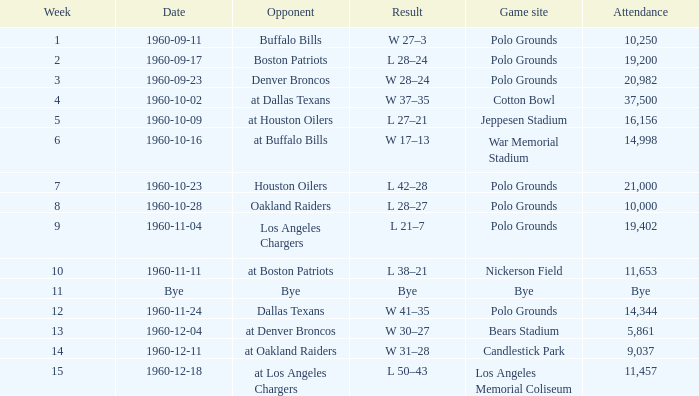I'm looking to parse the entire table for insights. Could you assist me with that? {'header': ['Week', 'Date', 'Opponent', 'Result', 'Game site', 'Attendance'], 'rows': [['1', '1960-09-11', 'Buffalo Bills', 'W 27–3', 'Polo Grounds', '10,250'], ['2', '1960-09-17', 'Boston Patriots', 'L 28–24', 'Polo Grounds', '19,200'], ['3', '1960-09-23', 'Denver Broncos', 'W 28–24', 'Polo Grounds', '20,982'], ['4', '1960-10-02', 'at Dallas Texans', 'W 37–35', 'Cotton Bowl', '37,500'], ['5', '1960-10-09', 'at Houston Oilers', 'L 27–21', 'Jeppesen Stadium', '16,156'], ['6', '1960-10-16', 'at Buffalo Bills', 'W 17–13', 'War Memorial Stadium', '14,998'], ['7', '1960-10-23', 'Houston Oilers', 'L 42–28', 'Polo Grounds', '21,000'], ['8', '1960-10-28', 'Oakland Raiders', 'L 28–27', 'Polo Grounds', '10,000'], ['9', '1960-11-04', 'Los Angeles Chargers', 'L 21–7', 'Polo Grounds', '19,402'], ['10', '1960-11-11', 'at Boston Patriots', 'L 38–21', 'Nickerson Field', '11,653'], ['11', 'Bye', 'Bye', 'Bye', 'Bye', 'Bye'], ['12', '1960-11-24', 'Dallas Texans', 'W 41–35', 'Polo Grounds', '14,344'], ['13', '1960-12-04', 'at Denver Broncos', 'W 30–27', 'Bears Stadium', '5,861'], ['14', '1960-12-11', 'at Oakland Raiders', 'W 31–28', 'Candlestick Park', '9,037'], ['15', '1960-12-18', 'at Los Angeles Chargers', 'L 50–43', 'Los Angeles Memorial Coliseum', '11,457']]} What day had 37,500 attending? 1960-10-02. 